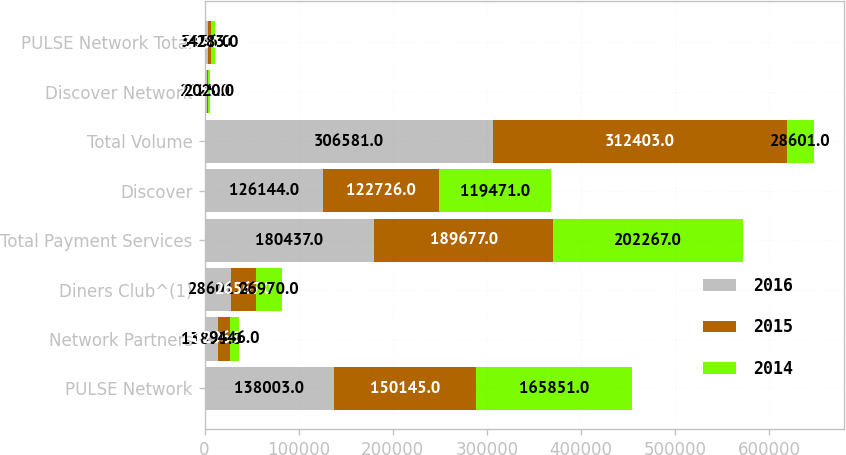<chart> <loc_0><loc_0><loc_500><loc_500><stacked_bar_chart><ecel><fcel>PULSE Network<fcel>Network Partners<fcel>Diners Club^(1)<fcel>Total Payment Services<fcel>Discover<fcel>Total Volume<fcel>Discover Network<fcel>PULSE Network Total<nl><fcel>2016<fcel>138003<fcel>13833<fcel>28601<fcel>180437<fcel>126144<fcel>306581<fcel>2125<fcel>3456<nl><fcel>2015<fcel>150145<fcel>12965<fcel>26567<fcel>189677<fcel>122726<fcel>312403<fcel>2033<fcel>3890<nl><fcel>2014<fcel>165851<fcel>9446<fcel>26970<fcel>202267<fcel>119471<fcel>28601<fcel>2020<fcel>4283<nl></chart> 